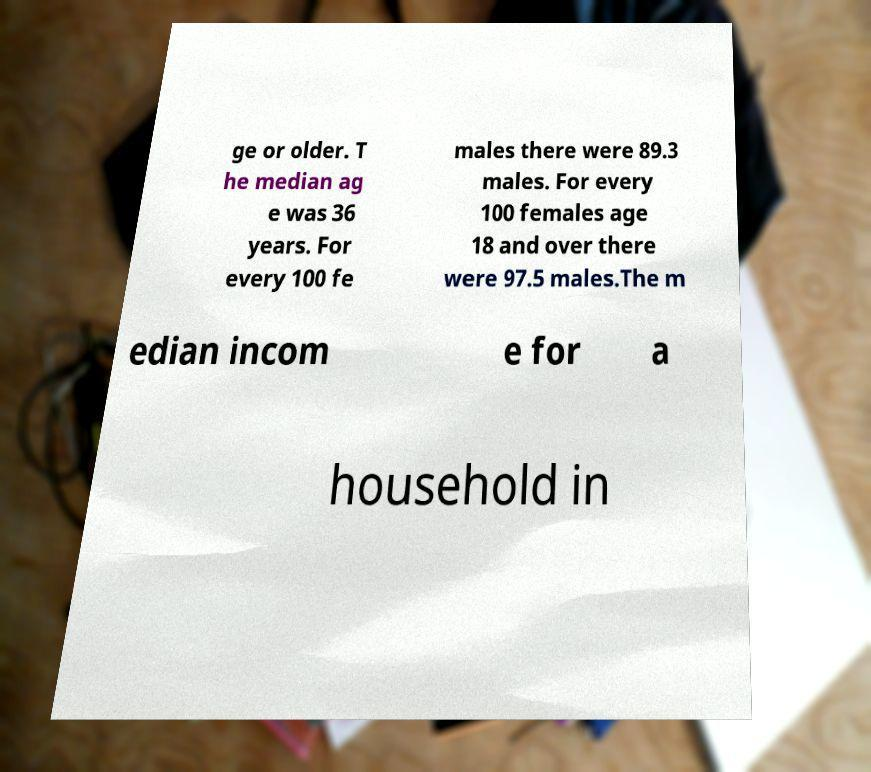There's text embedded in this image that I need extracted. Can you transcribe it verbatim? ge or older. T he median ag e was 36 years. For every 100 fe males there were 89.3 males. For every 100 females age 18 and over there were 97.5 males.The m edian incom e for a household in 